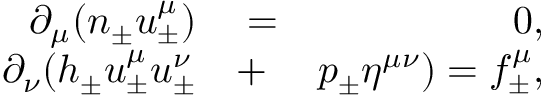<formula> <loc_0><loc_0><loc_500><loc_500>\begin{array} { r l r } { \partial _ { \mu } ( n _ { \pm } u _ { \pm } ^ { \mu } ) } & = } & { 0 , } \\ { \partial _ { \nu } ( h _ { \pm } u _ { \pm } ^ { \mu } u _ { \pm } ^ { \nu } } & + } & { p _ { \pm } \eta ^ { \mu \nu } ) = f _ { \pm } ^ { \mu } , } \end{array}</formula> 